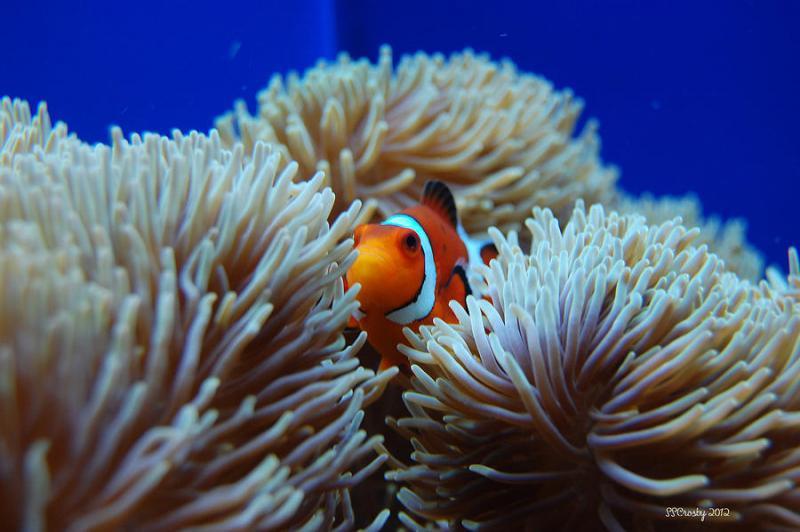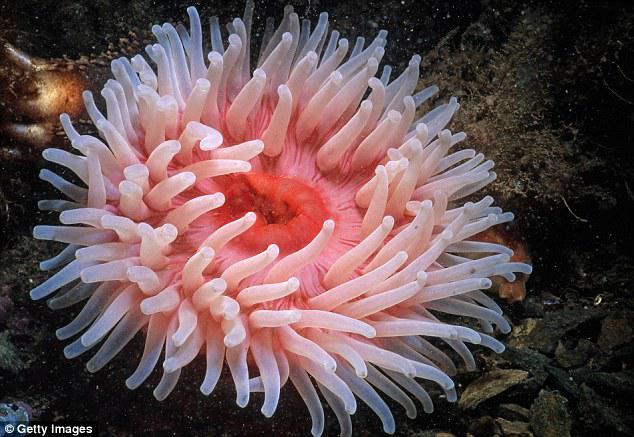The first image is the image on the left, the second image is the image on the right. For the images shown, is this caption "Both images show anemones with similar vibrant warm coloring." true? Answer yes or no. No. The first image is the image on the left, the second image is the image on the right. For the images shown, is this caption "An anemone looks like a pink flower with tubular monochromatic petals." true? Answer yes or no. Yes. The first image is the image on the left, the second image is the image on the right. Given the left and right images, does the statement "There is no more than one pink anemone." hold true? Answer yes or no. Yes. The first image is the image on the left, the second image is the image on the right. Analyze the images presented: Is the assertion "There are two or fewer fish across both images." valid? Answer yes or no. Yes. The first image is the image on the left, the second image is the image on the right. For the images shown, is this caption "An image shows a round pinkish anemone with monochrome, non-ombre tendrils." true? Answer yes or no. Yes. The first image is the image on the left, the second image is the image on the right. For the images displayed, is the sentence "An image shows an orange fish swimming amid green anemone tendrils, and the image contains multiple fish." factually correct? Answer yes or no. No. 